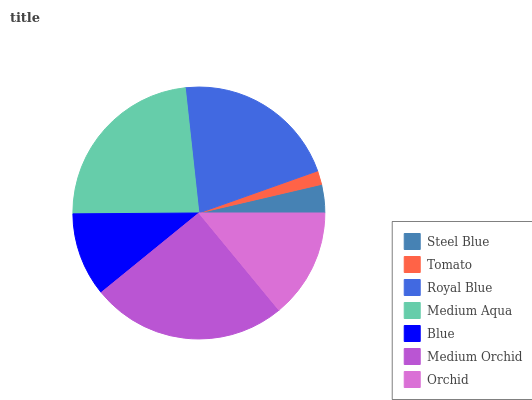Is Tomato the minimum?
Answer yes or no. Yes. Is Medium Orchid the maximum?
Answer yes or no. Yes. Is Royal Blue the minimum?
Answer yes or no. No. Is Royal Blue the maximum?
Answer yes or no. No. Is Royal Blue greater than Tomato?
Answer yes or no. Yes. Is Tomato less than Royal Blue?
Answer yes or no. Yes. Is Tomato greater than Royal Blue?
Answer yes or no. No. Is Royal Blue less than Tomato?
Answer yes or no. No. Is Orchid the high median?
Answer yes or no. Yes. Is Orchid the low median?
Answer yes or no. Yes. Is Medium Aqua the high median?
Answer yes or no. No. Is Steel Blue the low median?
Answer yes or no. No. 